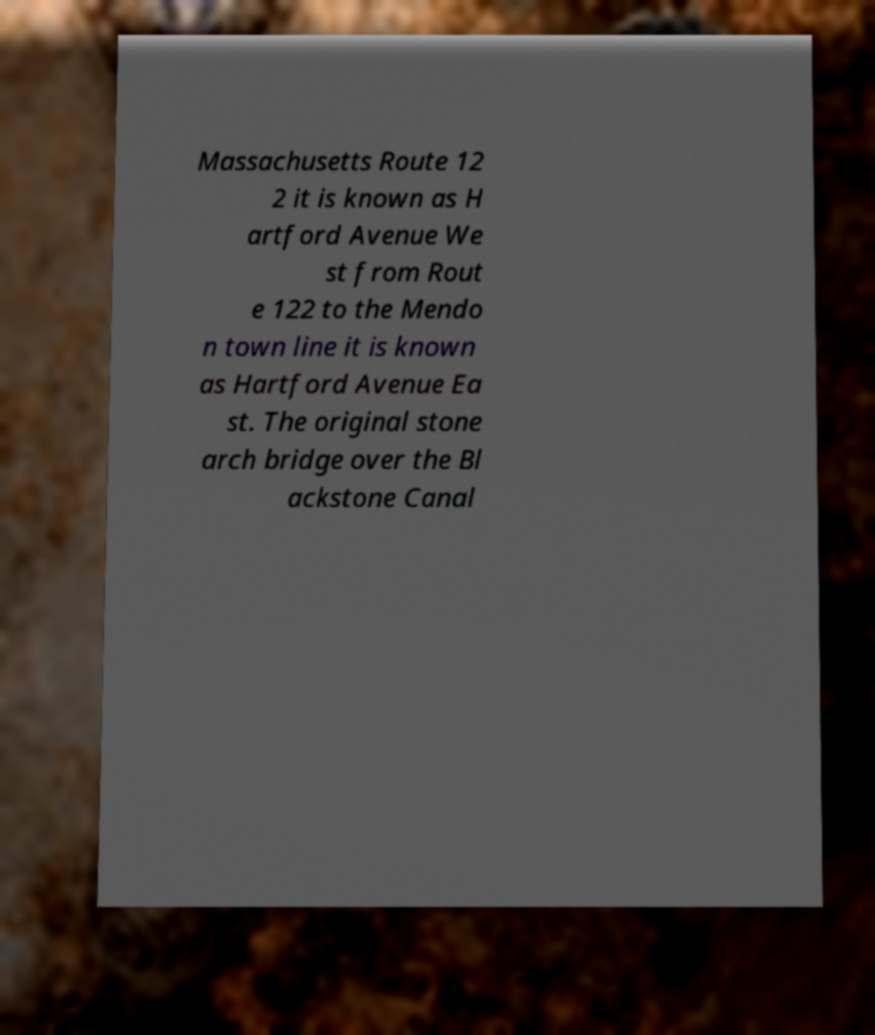Can you accurately transcribe the text from the provided image for me? Massachusetts Route 12 2 it is known as H artford Avenue We st from Rout e 122 to the Mendo n town line it is known as Hartford Avenue Ea st. The original stone arch bridge over the Bl ackstone Canal 